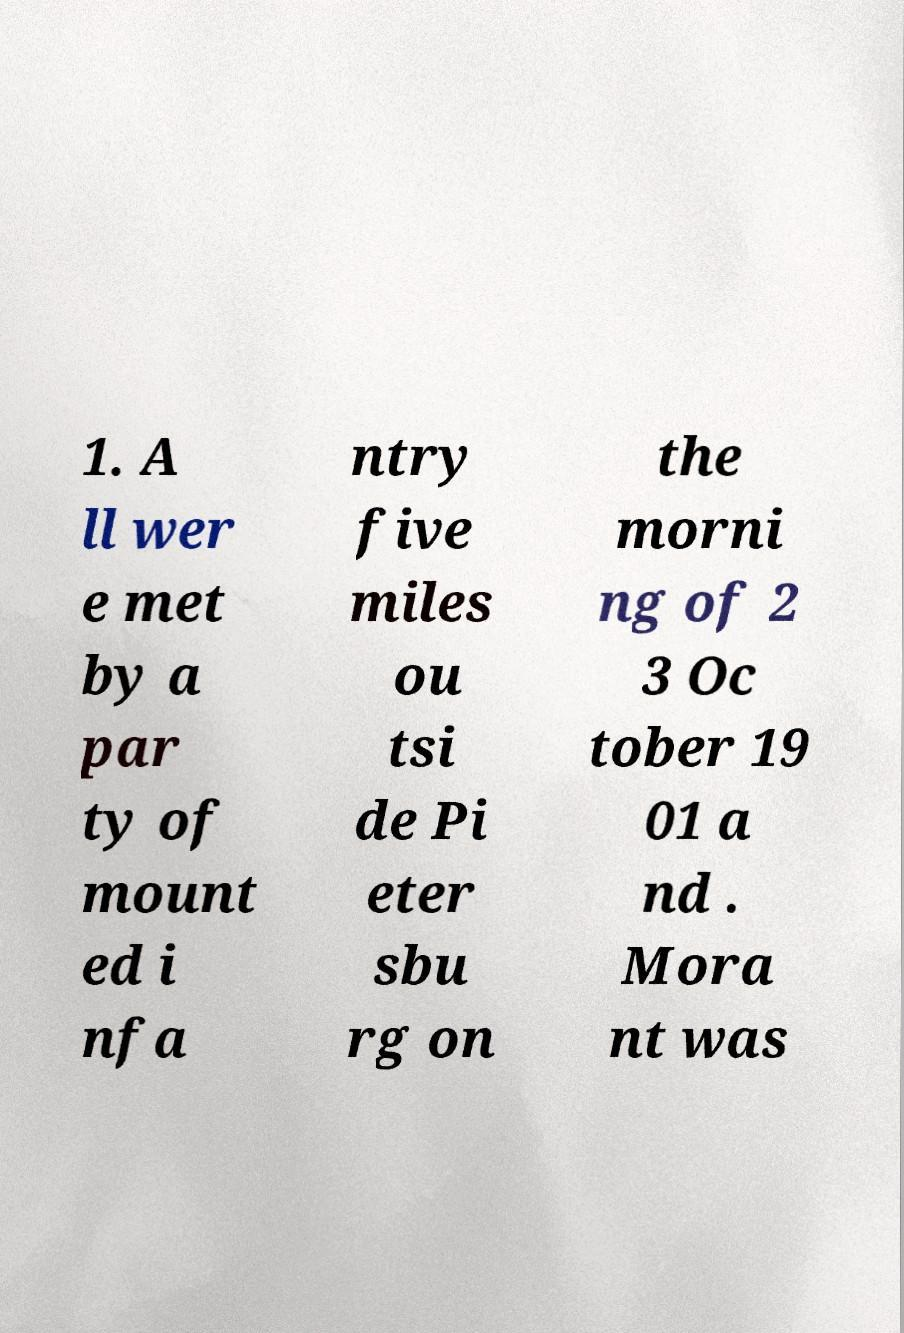Please read and relay the text visible in this image. What does it say? 1. A ll wer e met by a par ty of mount ed i nfa ntry five miles ou tsi de Pi eter sbu rg on the morni ng of 2 3 Oc tober 19 01 a nd . Mora nt was 